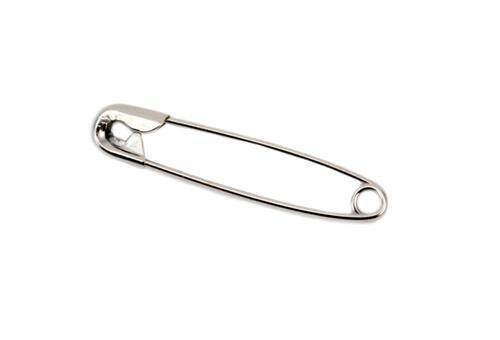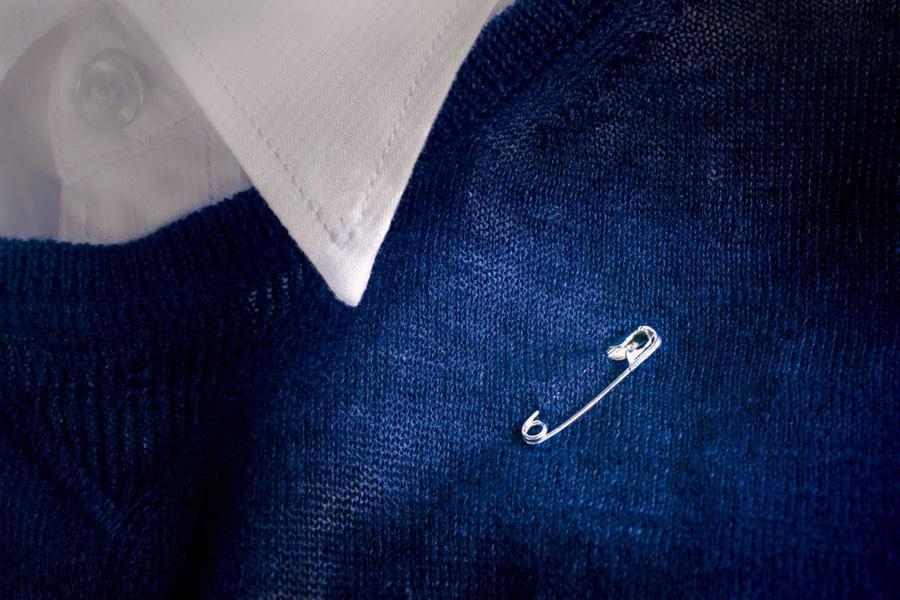The first image is the image on the left, the second image is the image on the right. Considering the images on both sides, is "At least one safety pin is pinned through a fabric." valid? Answer yes or no. Yes. 